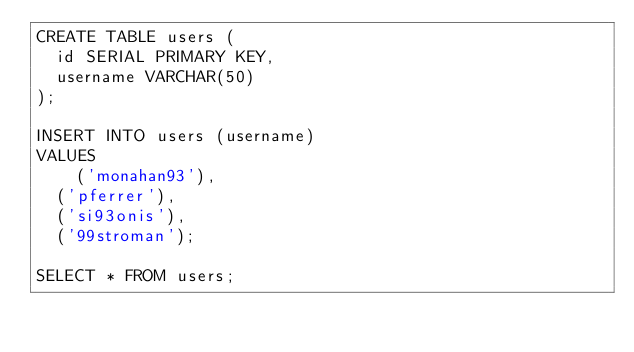Convert code to text. <code><loc_0><loc_0><loc_500><loc_500><_SQL_>CREATE TABLE users (
  id SERIAL PRIMARY KEY,
  username VARCHAR(50)
);

INSERT INTO users (username)
VALUES
	('monahan93'),
  ('pferrer'),
  ('si93onis'),
  ('99stroman');

SELECT * FROM users;</code> 